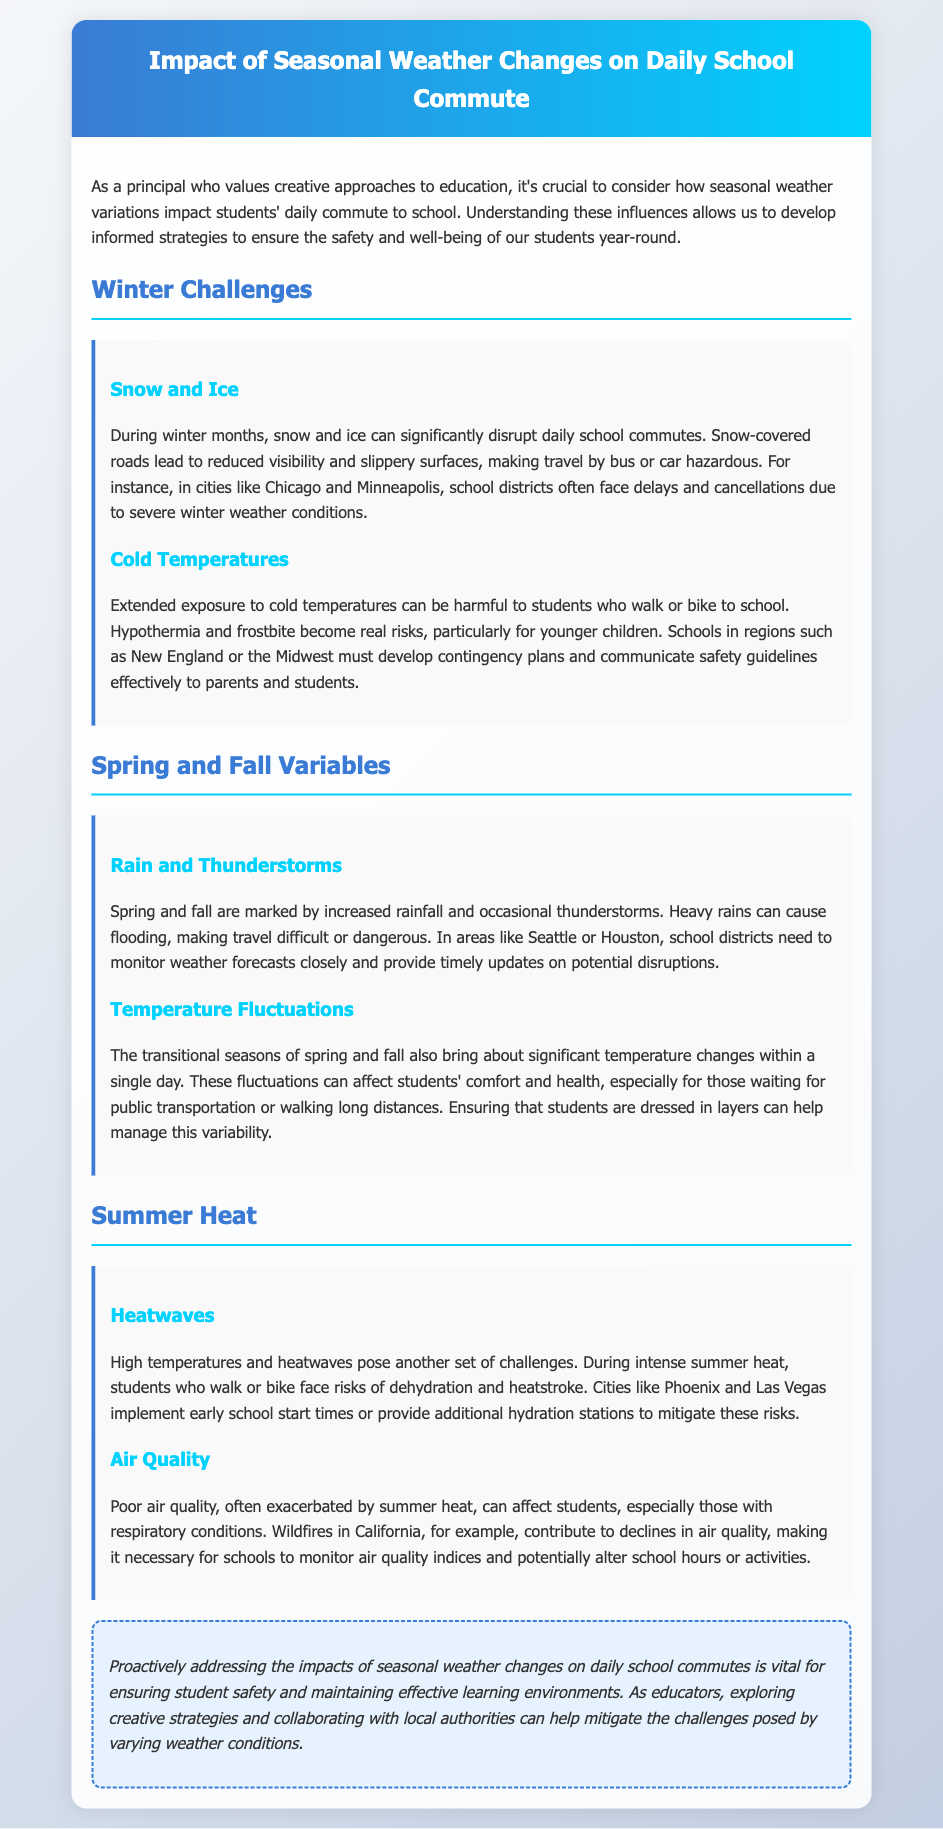what are two winter challenges mentioned? The document lists "Snow and Ice" and "Cold Temperatures" as winter challenges affecting school commutes.
Answer: Snow and Ice, Cold Temperatures which regions must develop contingency plans for cold risks? The document mentions that schools in regions such as New England or the Midwest must develop contingency plans.
Answer: New England, Midwest what types of weather affect spring and fall commutes? The document indicates that "Rain and Thunderstorms" and "Temperature Fluctuations" affect commutes during spring and fall.
Answer: Rain and Thunderstorms, Temperature Fluctuations what is a significant risk during summer heat? The document states that risks include dehydration and heatstroke, which are significant during high temperatures in summer.
Answer: Dehydration and heatstroke which cities implement early school start times due to heat? The document cites cities like Phoenix and Las Vegas as places that implement early school start times to mitigate summer heat risks.
Answer: Phoenix, Las Vegas what proactive approach is essential for student safety? The document emphasizes that proactively addressing the impacts of seasonal weather changes is vital for ensuring student safety.
Answer: Proactively addressing impacts what can schools monitor to address air quality issues? The document suggests that schools can monitor air quality indices to manage poor air quality problems during summer.
Answer: Air quality indices which type of document is this? The document is structured as a report discussing the impact of weather on school commuting.
Answer: Traffic report 